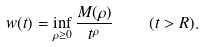Convert formula to latex. <formula><loc_0><loc_0><loc_500><loc_500>w ( t ) = \inf _ { \rho \geq 0 } \frac { M ( \rho ) } { t ^ { \rho } } \quad ( t > R ) .</formula> 